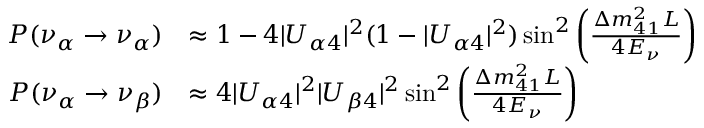Convert formula to latex. <formula><loc_0><loc_0><loc_500><loc_500>\begin{array} { r l } { P ( \nu _ { \alpha } \to \nu _ { \alpha } ) } & { \approx 1 - 4 | U _ { \alpha 4 } | ^ { 2 } ( 1 - | U _ { \alpha 4 } | ^ { 2 } ) \sin ^ { 2 } \left ( \frac { \Delta m _ { 4 1 } ^ { 2 } L } { 4 E _ { \nu } } \right ) } \\ { P ( \nu _ { \alpha } \to \nu _ { \beta } ) } & { \approx 4 | U _ { \alpha 4 } | ^ { 2 } | U _ { \beta 4 } | ^ { 2 } \sin ^ { 2 } \left ( \frac { \Delta m _ { 4 1 } ^ { 2 } L } { 4 E _ { \nu } } \right ) } \end{array}</formula> 